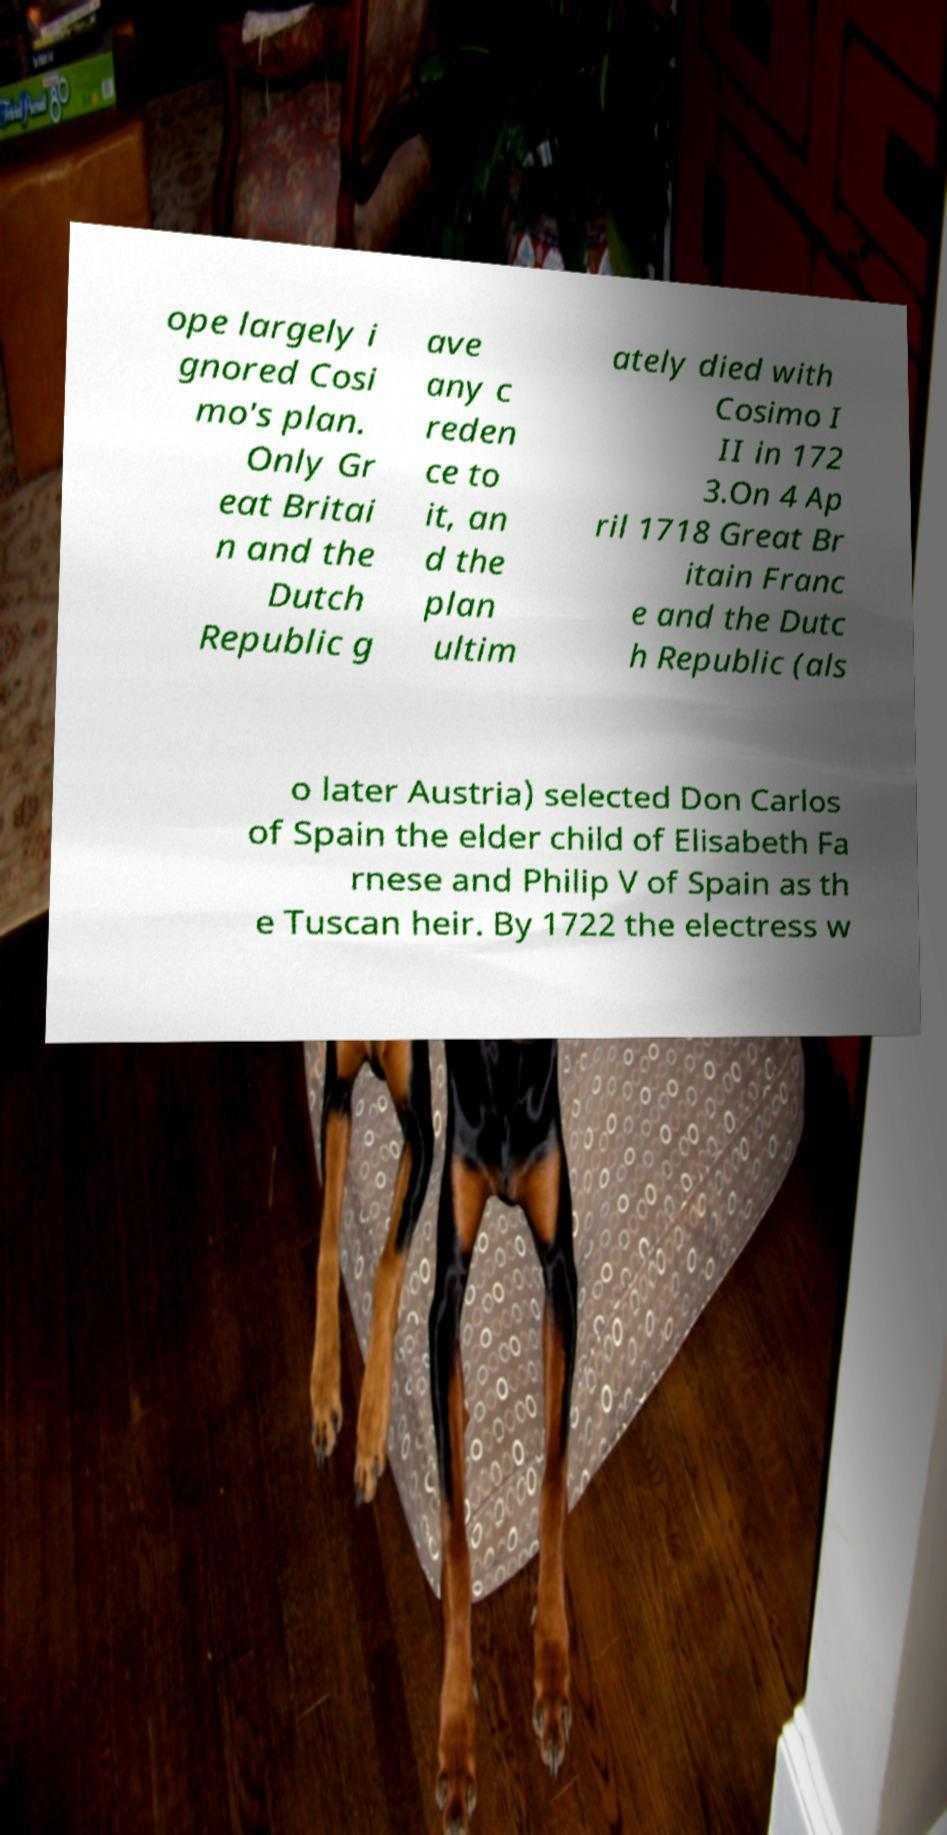Please identify and transcribe the text found in this image. ope largely i gnored Cosi mo's plan. Only Gr eat Britai n and the Dutch Republic g ave any c reden ce to it, an d the plan ultim ately died with Cosimo I II in 172 3.On 4 Ap ril 1718 Great Br itain Franc e and the Dutc h Republic (als o later Austria) selected Don Carlos of Spain the elder child of Elisabeth Fa rnese and Philip V of Spain as th e Tuscan heir. By 1722 the electress w 